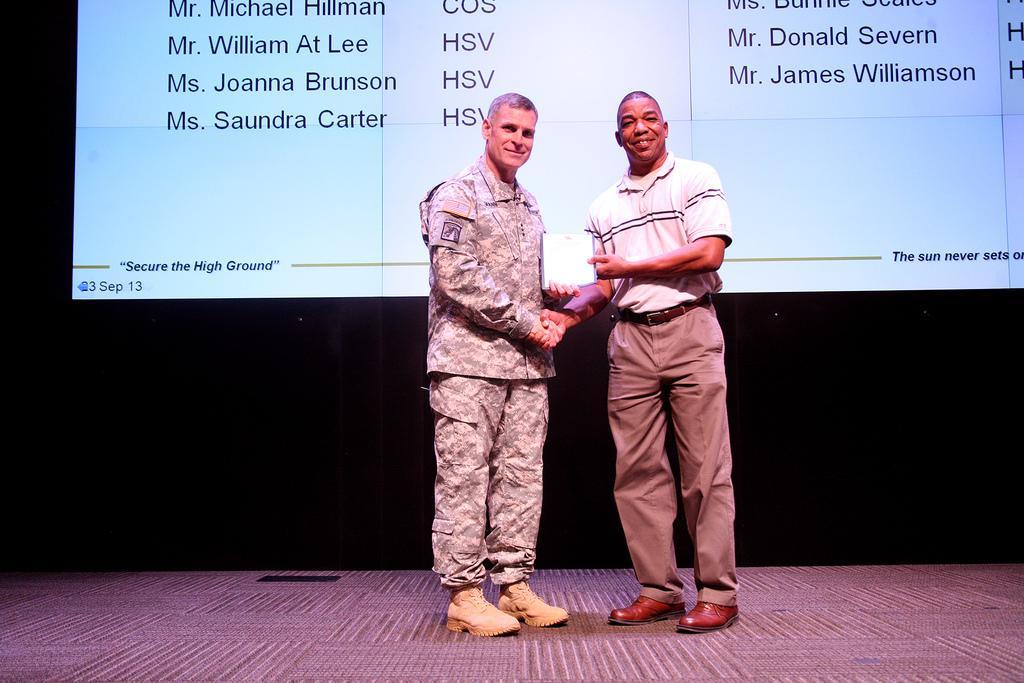Describe this image in one or two sentences. In this image we can see two persons are shaken-hanging and standing on the stage, behind them there is a screen. 